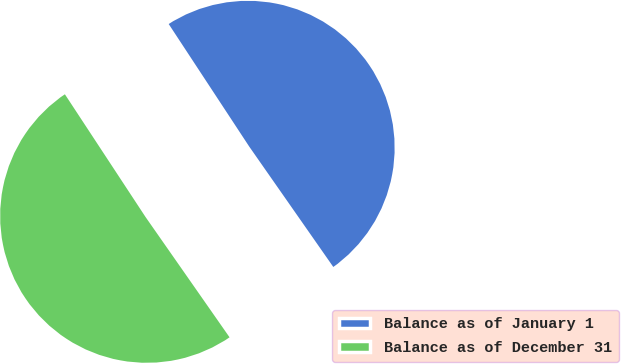<chart> <loc_0><loc_0><loc_500><loc_500><pie_chart><fcel>Balance as of January 1<fcel>Balance as of December 31<nl><fcel>49.55%<fcel>50.45%<nl></chart> 